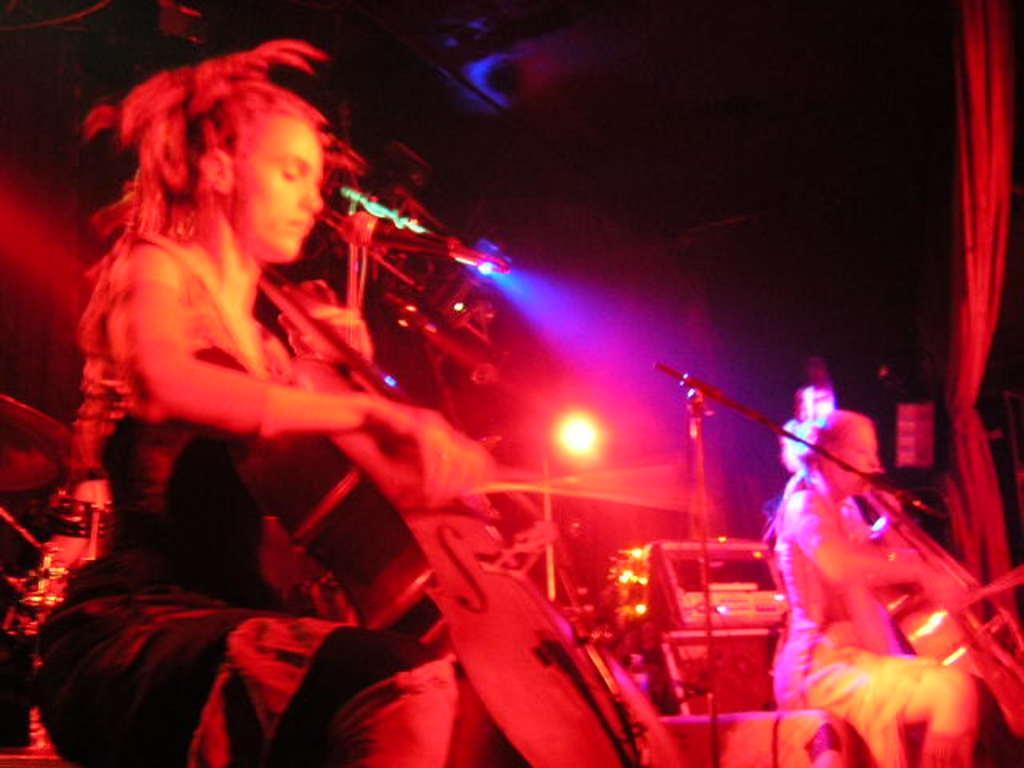In one or two sentences, can you explain what this image depicts? There are group of people playing music. 